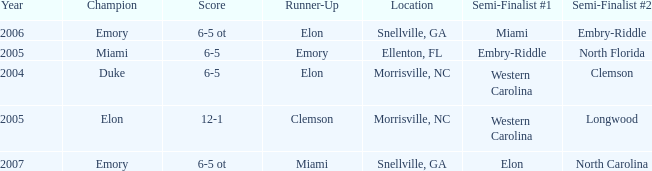When Embry-Riddle made it to the first semi finalist slot, list all the runners up. Emory. 